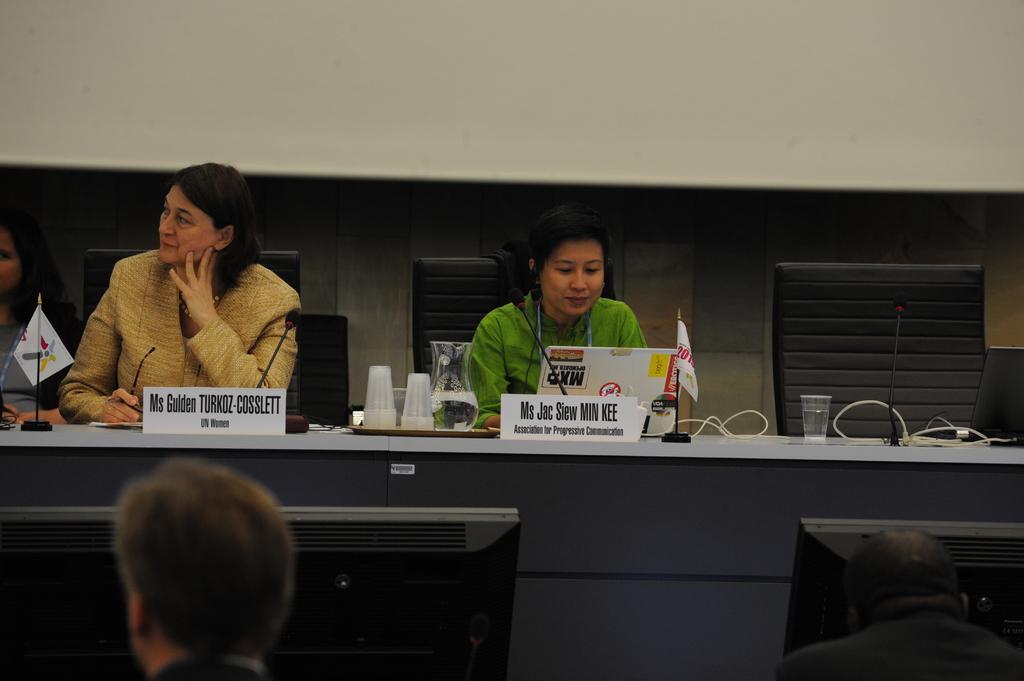Can you describe this image briefly? In the center of the image we can see two people sitting, before them there is a table and we can see glasses, laptop, flags, wires and a jug placed on the table. At the bottom we can see computers, mic and people. In the background there is a wall. 